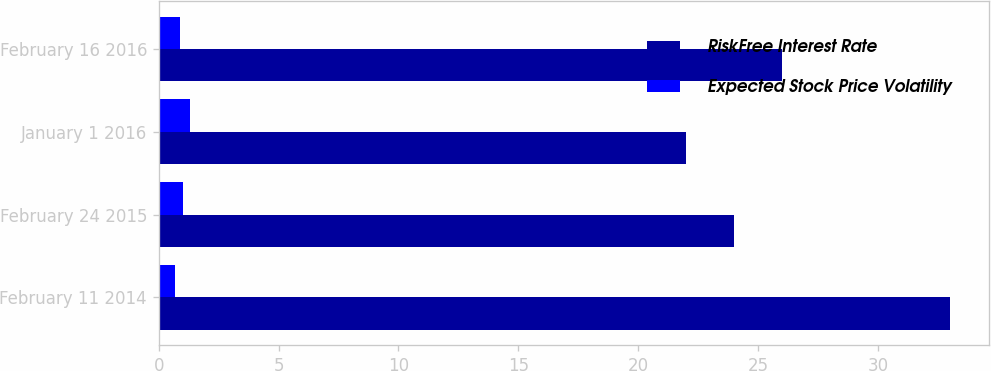<chart> <loc_0><loc_0><loc_500><loc_500><stacked_bar_chart><ecel><fcel>February 11 2014<fcel>February 24 2015<fcel>January 1 2016<fcel>February 16 2016<nl><fcel>RiskFree Interest Rate<fcel>33<fcel>24<fcel>22<fcel>26<nl><fcel>Expected Stock Price Volatility<fcel>0.67<fcel>1<fcel>1.32<fcel>0.89<nl></chart> 